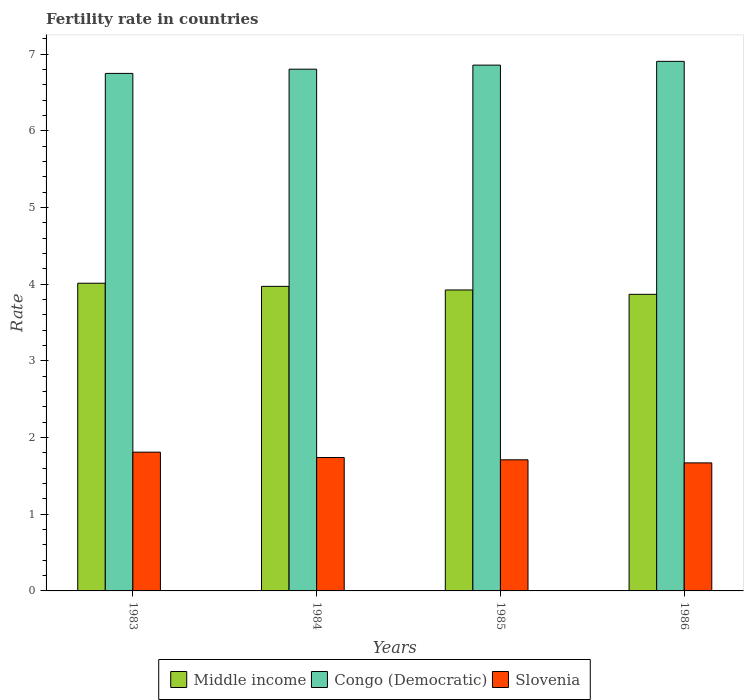How many different coloured bars are there?
Offer a very short reply. 3. How many groups of bars are there?
Provide a short and direct response. 4. Are the number of bars per tick equal to the number of legend labels?
Your answer should be compact. Yes. Are the number of bars on each tick of the X-axis equal?
Your response must be concise. Yes. How many bars are there on the 2nd tick from the right?
Ensure brevity in your answer.  3. What is the label of the 4th group of bars from the left?
Offer a very short reply. 1986. What is the fertility rate in Slovenia in 1986?
Offer a terse response. 1.67. Across all years, what is the maximum fertility rate in Congo (Democratic)?
Your response must be concise. 6.91. Across all years, what is the minimum fertility rate in Middle income?
Provide a short and direct response. 3.87. What is the total fertility rate in Slovenia in the graph?
Make the answer very short. 6.93. What is the difference between the fertility rate in Congo (Democratic) in 1984 and that in 1985?
Your answer should be compact. -0.05. What is the difference between the fertility rate in Middle income in 1986 and the fertility rate in Congo (Democratic) in 1985?
Give a very brief answer. -2.99. What is the average fertility rate in Congo (Democratic) per year?
Give a very brief answer. 6.83. In the year 1986, what is the difference between the fertility rate in Congo (Democratic) and fertility rate in Middle income?
Make the answer very short. 3.04. What is the ratio of the fertility rate in Middle income in 1983 to that in 1986?
Offer a terse response. 1.04. What is the difference between the highest and the second highest fertility rate in Middle income?
Give a very brief answer. 0.04. What is the difference between the highest and the lowest fertility rate in Slovenia?
Your answer should be very brief. 0.14. Is the sum of the fertility rate in Middle income in 1984 and 1986 greater than the maximum fertility rate in Slovenia across all years?
Ensure brevity in your answer.  Yes. What does the 1st bar from the right in 1984 represents?
Give a very brief answer. Slovenia. Is it the case that in every year, the sum of the fertility rate in Slovenia and fertility rate in Congo (Democratic) is greater than the fertility rate in Middle income?
Your answer should be compact. Yes. How many bars are there?
Provide a succinct answer. 12. How many years are there in the graph?
Provide a short and direct response. 4. What is the difference between two consecutive major ticks on the Y-axis?
Your answer should be very brief. 1. Are the values on the major ticks of Y-axis written in scientific E-notation?
Offer a very short reply. No. Does the graph contain any zero values?
Provide a short and direct response. No. Where does the legend appear in the graph?
Provide a short and direct response. Bottom center. How are the legend labels stacked?
Provide a succinct answer. Horizontal. What is the title of the graph?
Make the answer very short. Fertility rate in countries. Does "Sri Lanka" appear as one of the legend labels in the graph?
Your response must be concise. No. What is the label or title of the Y-axis?
Ensure brevity in your answer.  Rate. What is the Rate in Middle income in 1983?
Make the answer very short. 4.01. What is the Rate of Congo (Democratic) in 1983?
Keep it short and to the point. 6.75. What is the Rate of Slovenia in 1983?
Provide a succinct answer. 1.81. What is the Rate in Middle income in 1984?
Provide a short and direct response. 3.97. What is the Rate of Congo (Democratic) in 1984?
Provide a short and direct response. 6.8. What is the Rate in Slovenia in 1984?
Provide a short and direct response. 1.74. What is the Rate of Middle income in 1985?
Your answer should be compact. 3.93. What is the Rate in Congo (Democratic) in 1985?
Ensure brevity in your answer.  6.86. What is the Rate of Slovenia in 1985?
Give a very brief answer. 1.71. What is the Rate in Middle income in 1986?
Offer a very short reply. 3.87. What is the Rate of Congo (Democratic) in 1986?
Your answer should be very brief. 6.91. What is the Rate of Slovenia in 1986?
Ensure brevity in your answer.  1.67. Across all years, what is the maximum Rate of Middle income?
Offer a terse response. 4.01. Across all years, what is the maximum Rate of Congo (Democratic)?
Ensure brevity in your answer.  6.91. Across all years, what is the maximum Rate of Slovenia?
Ensure brevity in your answer.  1.81. Across all years, what is the minimum Rate of Middle income?
Keep it short and to the point. 3.87. Across all years, what is the minimum Rate of Congo (Democratic)?
Offer a terse response. 6.75. Across all years, what is the minimum Rate of Slovenia?
Give a very brief answer. 1.67. What is the total Rate in Middle income in the graph?
Give a very brief answer. 15.78. What is the total Rate in Congo (Democratic) in the graph?
Keep it short and to the point. 27.32. What is the total Rate in Slovenia in the graph?
Ensure brevity in your answer.  6.93. What is the difference between the Rate of Middle income in 1983 and that in 1984?
Your answer should be very brief. 0.04. What is the difference between the Rate in Congo (Democratic) in 1983 and that in 1984?
Ensure brevity in your answer.  -0.06. What is the difference between the Rate in Slovenia in 1983 and that in 1984?
Offer a terse response. 0.07. What is the difference between the Rate of Middle income in 1983 and that in 1985?
Offer a very short reply. 0.09. What is the difference between the Rate of Congo (Democratic) in 1983 and that in 1985?
Offer a terse response. -0.11. What is the difference between the Rate in Middle income in 1983 and that in 1986?
Your answer should be compact. 0.14. What is the difference between the Rate in Congo (Democratic) in 1983 and that in 1986?
Give a very brief answer. -0.16. What is the difference between the Rate of Slovenia in 1983 and that in 1986?
Make the answer very short. 0.14. What is the difference between the Rate of Middle income in 1984 and that in 1985?
Your response must be concise. 0.05. What is the difference between the Rate in Congo (Democratic) in 1984 and that in 1985?
Offer a terse response. -0.05. What is the difference between the Rate of Middle income in 1984 and that in 1986?
Give a very brief answer. 0.1. What is the difference between the Rate in Congo (Democratic) in 1984 and that in 1986?
Provide a short and direct response. -0.1. What is the difference between the Rate in Slovenia in 1984 and that in 1986?
Your answer should be compact. 0.07. What is the difference between the Rate of Middle income in 1985 and that in 1986?
Make the answer very short. 0.06. What is the difference between the Rate of Congo (Democratic) in 1985 and that in 1986?
Your answer should be very brief. -0.05. What is the difference between the Rate in Slovenia in 1985 and that in 1986?
Make the answer very short. 0.04. What is the difference between the Rate of Middle income in 1983 and the Rate of Congo (Democratic) in 1984?
Make the answer very short. -2.79. What is the difference between the Rate in Middle income in 1983 and the Rate in Slovenia in 1984?
Offer a terse response. 2.27. What is the difference between the Rate in Congo (Democratic) in 1983 and the Rate in Slovenia in 1984?
Provide a succinct answer. 5.01. What is the difference between the Rate of Middle income in 1983 and the Rate of Congo (Democratic) in 1985?
Your response must be concise. -2.84. What is the difference between the Rate in Middle income in 1983 and the Rate in Slovenia in 1985?
Provide a short and direct response. 2.3. What is the difference between the Rate in Congo (Democratic) in 1983 and the Rate in Slovenia in 1985?
Your response must be concise. 5.04. What is the difference between the Rate in Middle income in 1983 and the Rate in Congo (Democratic) in 1986?
Provide a succinct answer. -2.89. What is the difference between the Rate in Middle income in 1983 and the Rate in Slovenia in 1986?
Your answer should be very brief. 2.34. What is the difference between the Rate in Congo (Democratic) in 1983 and the Rate in Slovenia in 1986?
Make the answer very short. 5.08. What is the difference between the Rate of Middle income in 1984 and the Rate of Congo (Democratic) in 1985?
Your response must be concise. -2.89. What is the difference between the Rate of Middle income in 1984 and the Rate of Slovenia in 1985?
Keep it short and to the point. 2.26. What is the difference between the Rate in Congo (Democratic) in 1984 and the Rate in Slovenia in 1985?
Provide a short and direct response. 5.09. What is the difference between the Rate of Middle income in 1984 and the Rate of Congo (Democratic) in 1986?
Your response must be concise. -2.93. What is the difference between the Rate of Middle income in 1984 and the Rate of Slovenia in 1986?
Keep it short and to the point. 2.3. What is the difference between the Rate in Congo (Democratic) in 1984 and the Rate in Slovenia in 1986?
Your answer should be very brief. 5.13. What is the difference between the Rate of Middle income in 1985 and the Rate of Congo (Democratic) in 1986?
Provide a succinct answer. -2.98. What is the difference between the Rate in Middle income in 1985 and the Rate in Slovenia in 1986?
Offer a terse response. 2.26. What is the difference between the Rate of Congo (Democratic) in 1985 and the Rate of Slovenia in 1986?
Provide a short and direct response. 5.19. What is the average Rate of Middle income per year?
Your answer should be compact. 3.94. What is the average Rate of Congo (Democratic) per year?
Your answer should be very brief. 6.83. What is the average Rate of Slovenia per year?
Your answer should be compact. 1.73. In the year 1983, what is the difference between the Rate of Middle income and Rate of Congo (Democratic)?
Provide a short and direct response. -2.74. In the year 1983, what is the difference between the Rate of Middle income and Rate of Slovenia?
Give a very brief answer. 2.2. In the year 1983, what is the difference between the Rate of Congo (Democratic) and Rate of Slovenia?
Your answer should be compact. 4.94. In the year 1984, what is the difference between the Rate in Middle income and Rate in Congo (Democratic)?
Ensure brevity in your answer.  -2.83. In the year 1984, what is the difference between the Rate in Middle income and Rate in Slovenia?
Your response must be concise. 2.23. In the year 1984, what is the difference between the Rate of Congo (Democratic) and Rate of Slovenia?
Offer a very short reply. 5.07. In the year 1985, what is the difference between the Rate of Middle income and Rate of Congo (Democratic)?
Offer a terse response. -2.93. In the year 1985, what is the difference between the Rate of Middle income and Rate of Slovenia?
Ensure brevity in your answer.  2.22. In the year 1985, what is the difference between the Rate in Congo (Democratic) and Rate in Slovenia?
Offer a terse response. 5.15. In the year 1986, what is the difference between the Rate in Middle income and Rate in Congo (Democratic)?
Your response must be concise. -3.04. In the year 1986, what is the difference between the Rate of Middle income and Rate of Slovenia?
Provide a succinct answer. 2.2. In the year 1986, what is the difference between the Rate in Congo (Democratic) and Rate in Slovenia?
Ensure brevity in your answer.  5.24. What is the ratio of the Rate of Middle income in 1983 to that in 1984?
Provide a short and direct response. 1.01. What is the ratio of the Rate in Congo (Democratic) in 1983 to that in 1984?
Keep it short and to the point. 0.99. What is the ratio of the Rate of Slovenia in 1983 to that in 1984?
Provide a succinct answer. 1.04. What is the ratio of the Rate in Middle income in 1983 to that in 1985?
Your answer should be very brief. 1.02. What is the ratio of the Rate in Congo (Democratic) in 1983 to that in 1985?
Your answer should be very brief. 0.98. What is the ratio of the Rate in Slovenia in 1983 to that in 1985?
Your answer should be compact. 1.06. What is the ratio of the Rate in Middle income in 1983 to that in 1986?
Provide a succinct answer. 1.04. What is the ratio of the Rate of Congo (Democratic) in 1983 to that in 1986?
Your response must be concise. 0.98. What is the ratio of the Rate in Slovenia in 1983 to that in 1986?
Your answer should be compact. 1.08. What is the ratio of the Rate in Congo (Democratic) in 1984 to that in 1985?
Your answer should be very brief. 0.99. What is the ratio of the Rate of Slovenia in 1984 to that in 1985?
Your answer should be very brief. 1.02. What is the ratio of the Rate of Middle income in 1984 to that in 1986?
Offer a terse response. 1.03. What is the ratio of the Rate in Congo (Democratic) in 1984 to that in 1986?
Keep it short and to the point. 0.99. What is the ratio of the Rate of Slovenia in 1984 to that in 1986?
Your answer should be very brief. 1.04. What is the ratio of the Rate in Middle income in 1985 to that in 1986?
Offer a terse response. 1.01. What is the ratio of the Rate of Congo (Democratic) in 1985 to that in 1986?
Your response must be concise. 0.99. What is the ratio of the Rate of Slovenia in 1985 to that in 1986?
Offer a very short reply. 1.02. What is the difference between the highest and the second highest Rate of Middle income?
Keep it short and to the point. 0.04. What is the difference between the highest and the second highest Rate of Congo (Democratic)?
Ensure brevity in your answer.  0.05. What is the difference between the highest and the second highest Rate of Slovenia?
Offer a terse response. 0.07. What is the difference between the highest and the lowest Rate in Middle income?
Your answer should be very brief. 0.14. What is the difference between the highest and the lowest Rate in Congo (Democratic)?
Provide a succinct answer. 0.16. What is the difference between the highest and the lowest Rate in Slovenia?
Give a very brief answer. 0.14. 